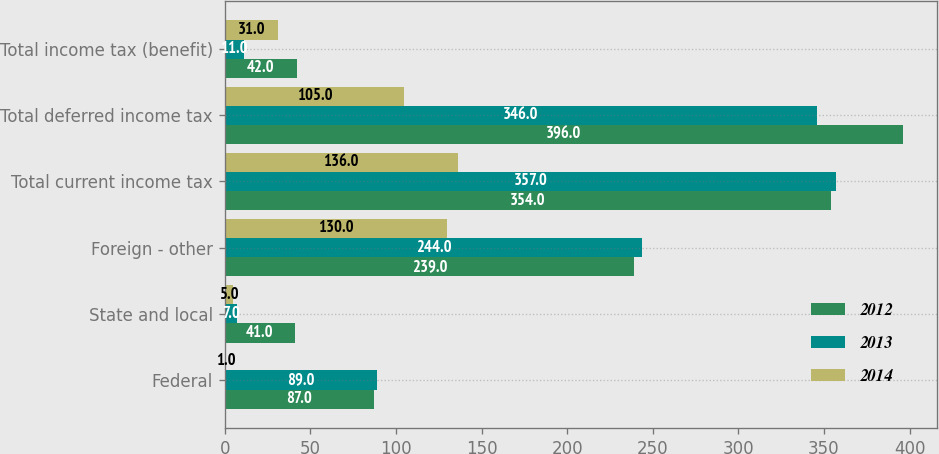Convert chart to OTSL. <chart><loc_0><loc_0><loc_500><loc_500><stacked_bar_chart><ecel><fcel>Federal<fcel>State and local<fcel>Foreign - other<fcel>Total current income tax<fcel>Total deferred income tax<fcel>Total income tax (benefit)<nl><fcel>2012<fcel>87<fcel>41<fcel>239<fcel>354<fcel>396<fcel>42<nl><fcel>2013<fcel>89<fcel>7<fcel>244<fcel>357<fcel>346<fcel>11<nl><fcel>2014<fcel>1<fcel>5<fcel>130<fcel>136<fcel>105<fcel>31<nl></chart> 